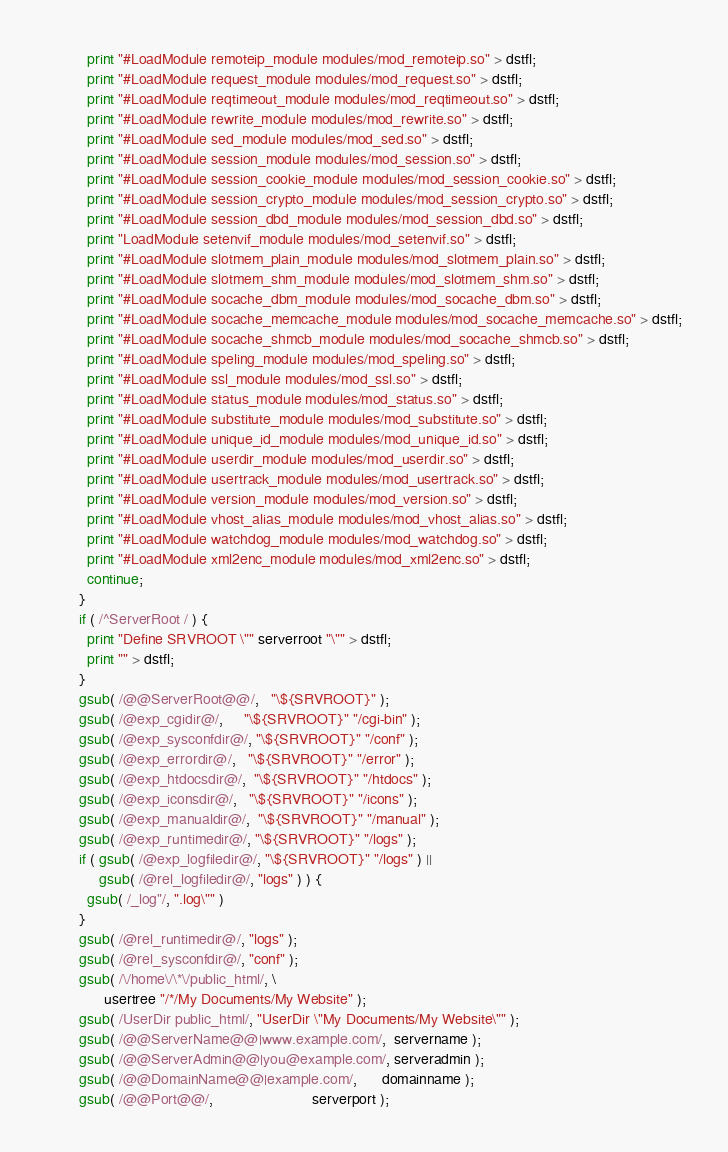<code> <loc_0><loc_0><loc_500><loc_500><_Awk_>          print "#LoadModule remoteip_module modules/mod_remoteip.so" > dstfl;
          print "#LoadModule request_module modules/mod_request.so" > dstfl;
          print "#LoadModule reqtimeout_module modules/mod_reqtimeout.so" > dstfl;
          print "#LoadModule rewrite_module modules/mod_rewrite.so" > dstfl;
          print "#LoadModule sed_module modules/mod_sed.so" > dstfl;
          print "#LoadModule session_module modules/mod_session.so" > dstfl;
          print "#LoadModule session_cookie_module modules/mod_session_cookie.so" > dstfl;
          print "#LoadModule session_crypto_module modules/mod_session_crypto.so" > dstfl;
          print "#LoadModule session_dbd_module modules/mod_session_dbd.so" > dstfl;
          print "LoadModule setenvif_module modules/mod_setenvif.so" > dstfl;
          print "#LoadModule slotmem_plain_module modules/mod_slotmem_plain.so" > dstfl;
          print "#LoadModule slotmem_shm_module modules/mod_slotmem_shm.so" > dstfl;
          print "#LoadModule socache_dbm_module modules/mod_socache_dbm.so" > dstfl;
          print "#LoadModule socache_memcache_module modules/mod_socache_memcache.so" > dstfl;
          print "#LoadModule socache_shmcb_module modules/mod_socache_shmcb.so" > dstfl;
          print "#LoadModule speling_module modules/mod_speling.so" > dstfl;
          print "#LoadModule ssl_module modules/mod_ssl.so" > dstfl;
          print "#LoadModule status_module modules/mod_status.so" > dstfl;
          print "#LoadModule substitute_module modules/mod_substitute.so" > dstfl;
          print "#LoadModule unique_id_module modules/mod_unique_id.so" > dstfl;
          print "#LoadModule userdir_module modules/mod_userdir.so" > dstfl;
          print "#LoadModule usertrack_module modules/mod_usertrack.so" > dstfl;
          print "#LoadModule version_module modules/mod_version.so" > dstfl;
          print "#LoadModule vhost_alias_module modules/mod_vhost_alias.so" > dstfl;
          print "#LoadModule watchdog_module modules/mod_watchdog.so" > dstfl;
          print "#LoadModule xml2enc_module modules/mod_xml2enc.so" > dstfl;
          continue;
        }
        if ( /^ServerRoot / ) {
          print "Define SRVROOT \"" serverroot "\"" > dstfl;
          print "" > dstfl;
        }
        gsub( /@@ServerRoot@@/,   "\${SRVROOT}" );
        gsub( /@exp_cgidir@/,     "\${SRVROOT}" "/cgi-bin" );
        gsub( /@exp_sysconfdir@/, "\${SRVROOT}" "/conf" );
        gsub( /@exp_errordir@/,   "\${SRVROOT}" "/error" );
        gsub( /@exp_htdocsdir@/,  "\${SRVROOT}" "/htdocs" );
        gsub( /@exp_iconsdir@/,   "\${SRVROOT}" "/icons" );
        gsub( /@exp_manualdir@/,  "\${SRVROOT}" "/manual" );
        gsub( /@exp_runtimedir@/, "\${SRVROOT}" "/logs" );
        if ( gsub( /@exp_logfiledir@/, "\${SRVROOT}" "/logs" ) ||
             gsub( /@rel_logfiledir@/, "logs" ) ) {
          gsub( /_log"/, ".log\"" )
        }
        gsub( /@rel_runtimedir@/, "logs" );
        gsub( /@rel_sysconfdir@/, "conf" );
        gsub( /\/home\/\*\/public_html/, \
              usertree "/*/My Documents/My Website" );
        gsub( /UserDir public_html/, "UserDir \"My Documents/My Website\"" );
        gsub( /@@ServerName@@|www.example.com/,  servername );
        gsub( /@@ServerAdmin@@|you@example.com/, serveradmin );
        gsub( /@@DomainName@@|example.com/,      domainname );
        gsub( /@@Port@@/,                        serverport );</code> 